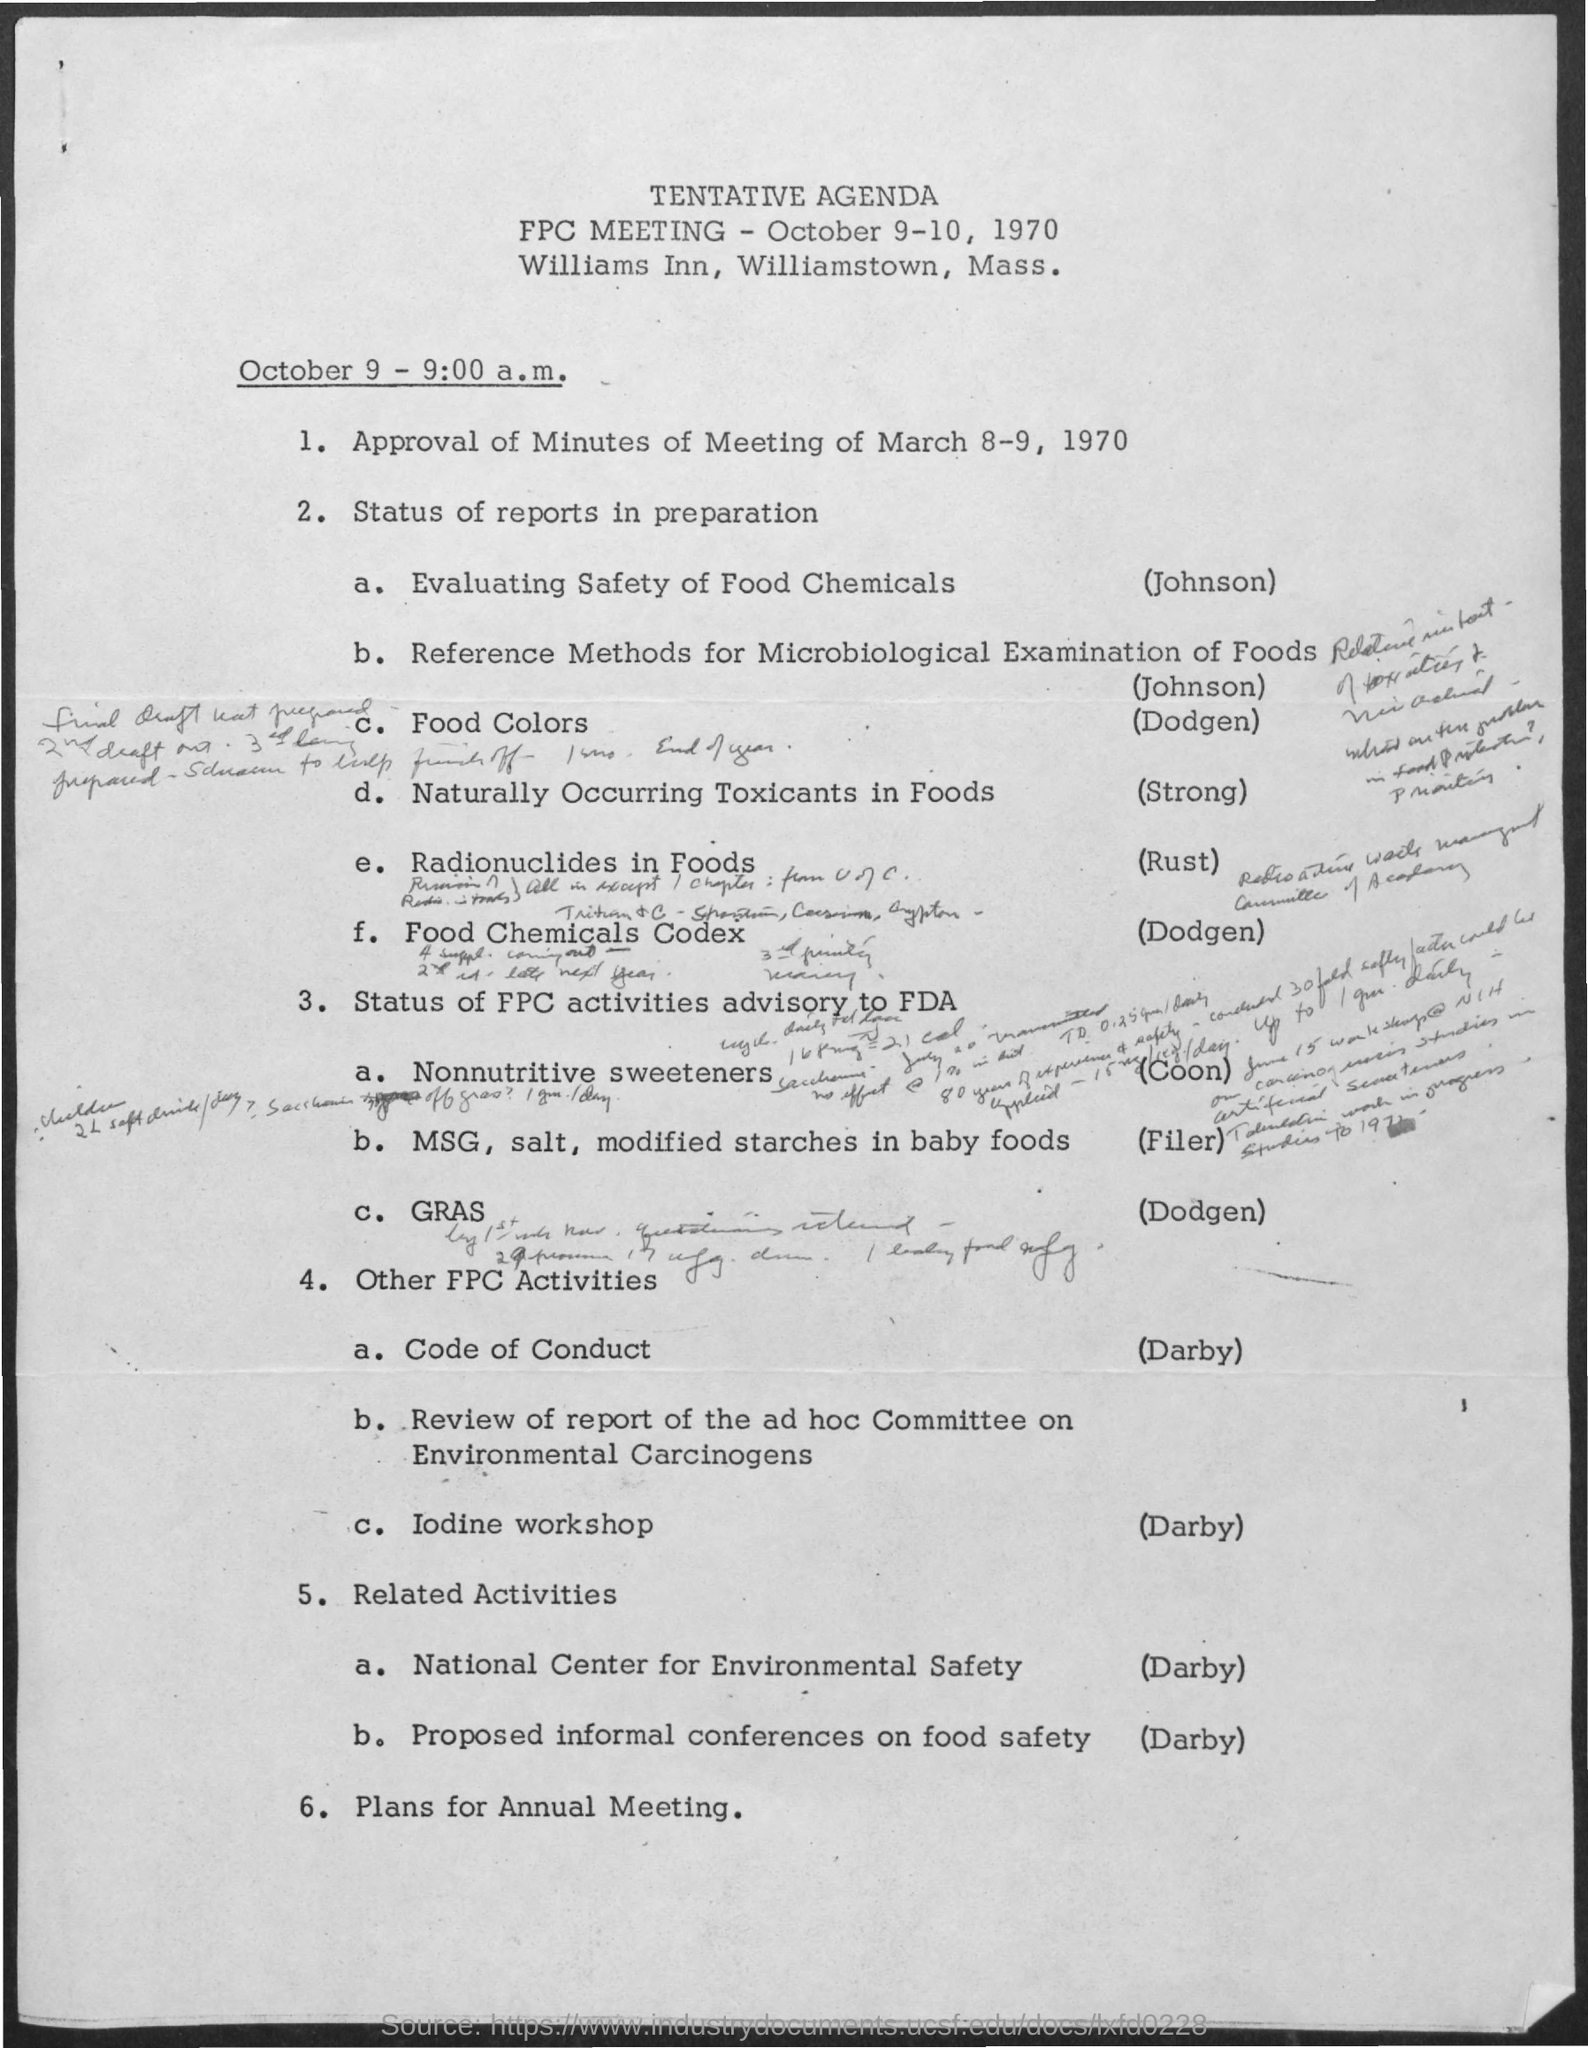Outline some significant characteristics in this image. The evaluating the safety of food chemicals was done by Johnson in the given agenda. The given meetings are scheduled to take place on October 9th and 10th, 1970. The given agenda mentions a meeting named "FPC meeting. 